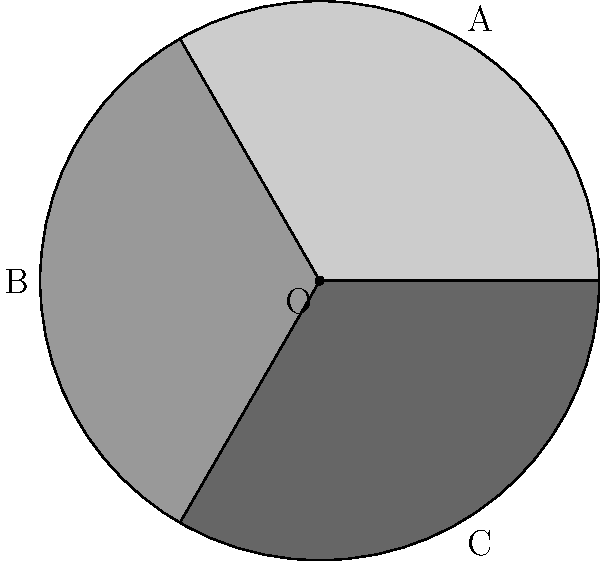In a lung CT scan image, three circular segments A, B, and C represent different regions of the lung. Segment A covers an angle of 120°, segment B covers 120°, and segment C covers 120°. If the total area of the lung in the image is 54π cm², what is the area of segment B? How might this information be used in assessing lung health? Let's approach this step-by-step:

1) First, we need to understand what the question is asking. We have a circular lung CT scan divided into three equal segments, each covering 120°.

2) The total area of the lung (full circle) is given as 54π cm².

3) To find the area of segment B, we need to:
   a) Calculate the area of the sector
   b) Calculate the area of the triangle formed by the two radii
   c) Subtract the triangle area from the sector area

4) The formula for the area of a circular sector is:
   $A_{sector} = \frac{\theta}{360°} \times \pi r^2$
   Where θ is the central angle in degrees and r is the radius.

5) In this case, θ = 120° and πr² = 54π cm²

6) Area of the sector:
   $A_{sector} = \frac{120}{360} \times 54\pi = 18\pi$ cm²

7) For the triangle area, we need the radius. We can find this from the total area:
   $54\pi = \pi r^2$
   $r^2 = 54$
   $r = \sqrt{54} = 3\sqrt{6}$ cm

8) The area of the triangle is:
   $A_{triangle} = \frac{1}{2} \times r^2 \times \sin(120°)$
   $= \frac{1}{2} \times 54 \times \frac{\sqrt{3}}{2} = \frac{27\sqrt{3}}{2}$ cm²

9) Therefore, the area of segment B is:
   $A_{segment} = A_{sector} - A_{triangle}$
   $= 18\pi - \frac{27\sqrt{3}}{2}$ cm²

This information can be used in assessing lung health by comparing the areas of different segments. Equal areas might indicate healthy, symmetrical lung function, while significant differences could suggest areas of concern requiring further investigation.
Answer: $18\pi - \frac{27\sqrt{3}}{2}$ cm² 